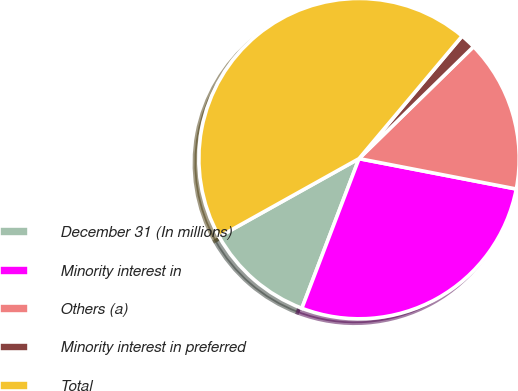Convert chart to OTSL. <chart><loc_0><loc_0><loc_500><loc_500><pie_chart><fcel>December 31 (In millions)<fcel>Minority interest in<fcel>Others (a)<fcel>Minority interest in preferred<fcel>Total<nl><fcel>11.09%<fcel>27.77%<fcel>15.36%<fcel>1.55%<fcel>44.23%<nl></chart> 